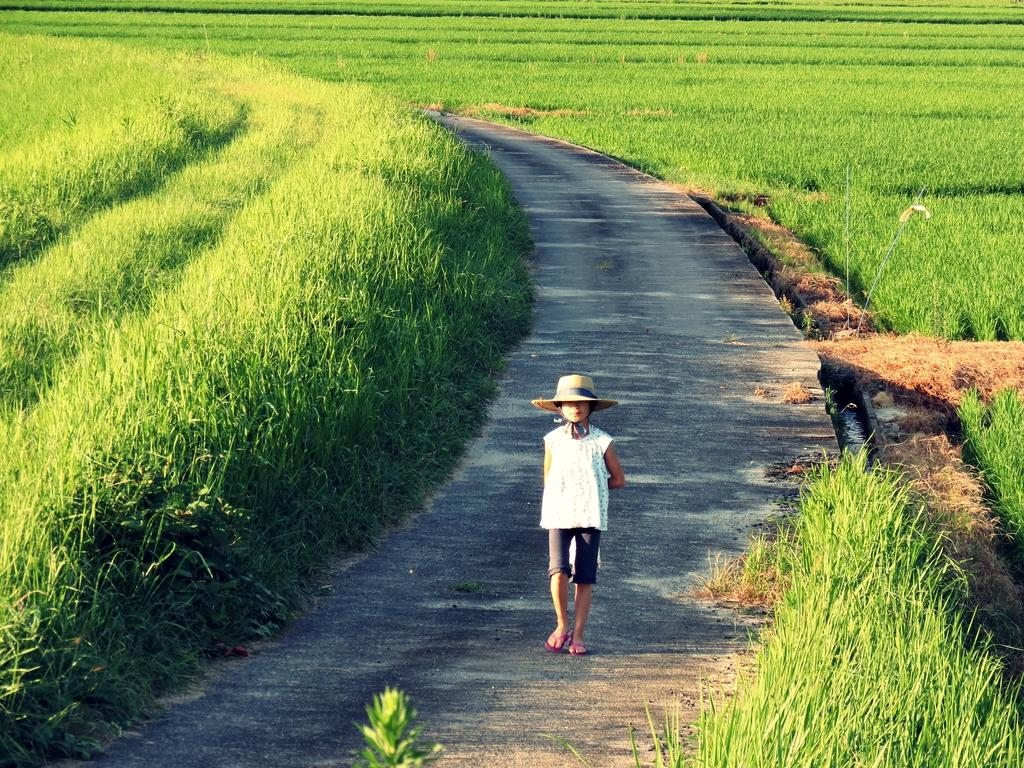What is the main subject of the image? The main subject of the image is a boy. What is the boy wearing in the image? The boy is wearing a hat in the image. What is the boy doing in the image? The boy is walking on the road in the image. What type of natural environment is visible in the image? There is grass visible in the image. What type of territory does the boy represent in the image? There is no indication in the image that the boy represents any territory. 